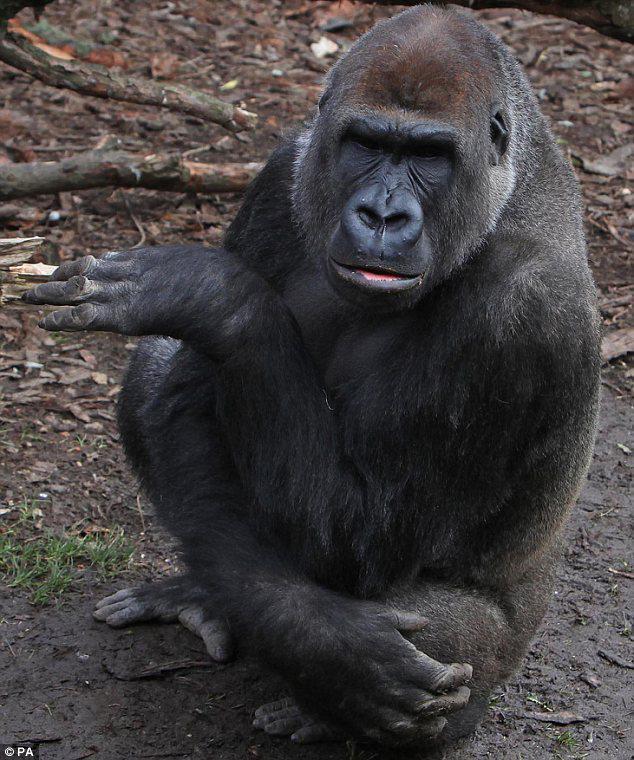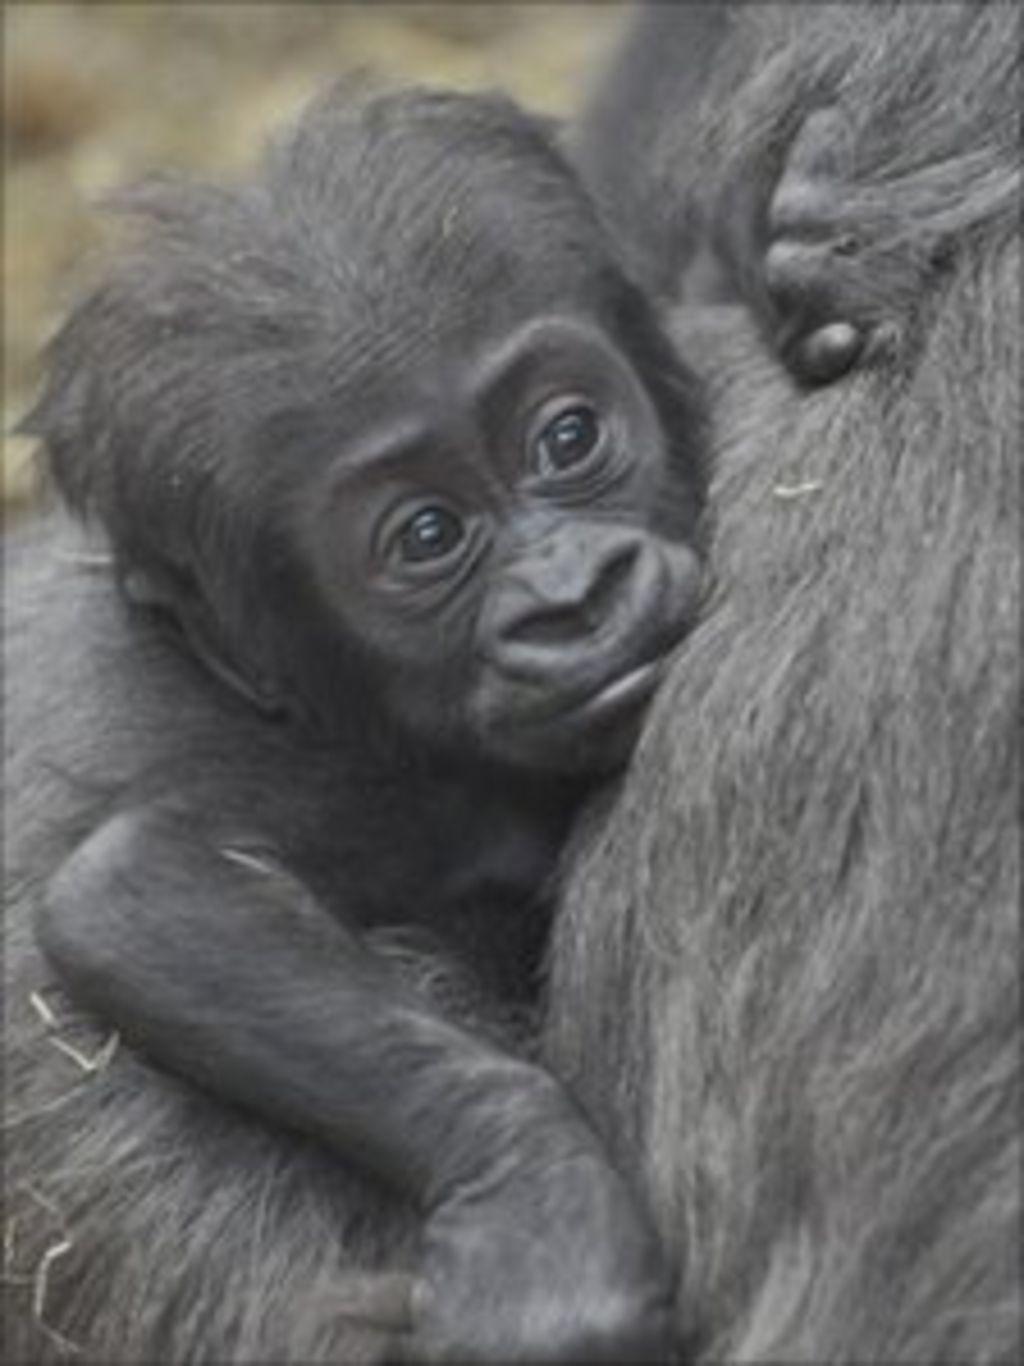The first image is the image on the left, the second image is the image on the right. For the images shown, is this caption "One of the gorillas is touching its face with its left hand." true? Answer yes or no. No. The first image is the image on the left, the second image is the image on the right. Given the left and right images, does the statement "Atleast one photo has a baby monkey looking to the right" hold true? Answer yes or no. Yes. The first image is the image on the left, the second image is the image on the right. Assess this claim about the two images: "A gorilla is holding a baby gorilla in its arms.". Correct or not? Answer yes or no. Yes. The first image is the image on the left, the second image is the image on the right. Evaluate the accuracy of this statement regarding the images: "The left image shows a mother gorilla's bent arm around a baby gorilla held to her chest and her other arm held up to her face.". Is it true? Answer yes or no. No. 